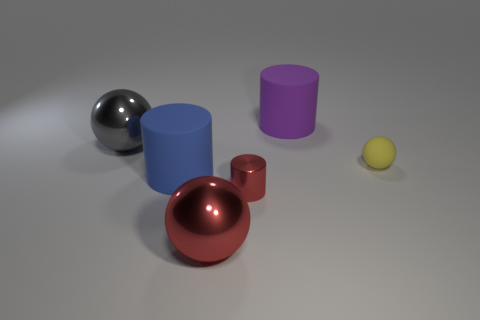Subtract all small yellow balls. How many balls are left? 2 Add 3 big red shiny balls. How many objects exist? 9 Subtract all red cylinders. How many cylinders are left? 2 Add 6 balls. How many balls exist? 9 Subtract 1 yellow spheres. How many objects are left? 5 Subtract 2 cylinders. How many cylinders are left? 1 Subtract all blue cylinders. Subtract all gray cubes. How many cylinders are left? 2 Subtract all green cylinders. How many red balls are left? 1 Subtract all gray metal spheres. Subtract all small metal objects. How many objects are left? 4 Add 3 tiny red shiny cylinders. How many tiny red shiny cylinders are left? 4 